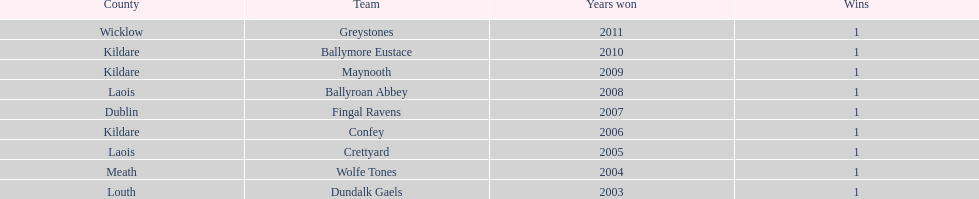What is the difference years won for crettyard and greystones 6. 